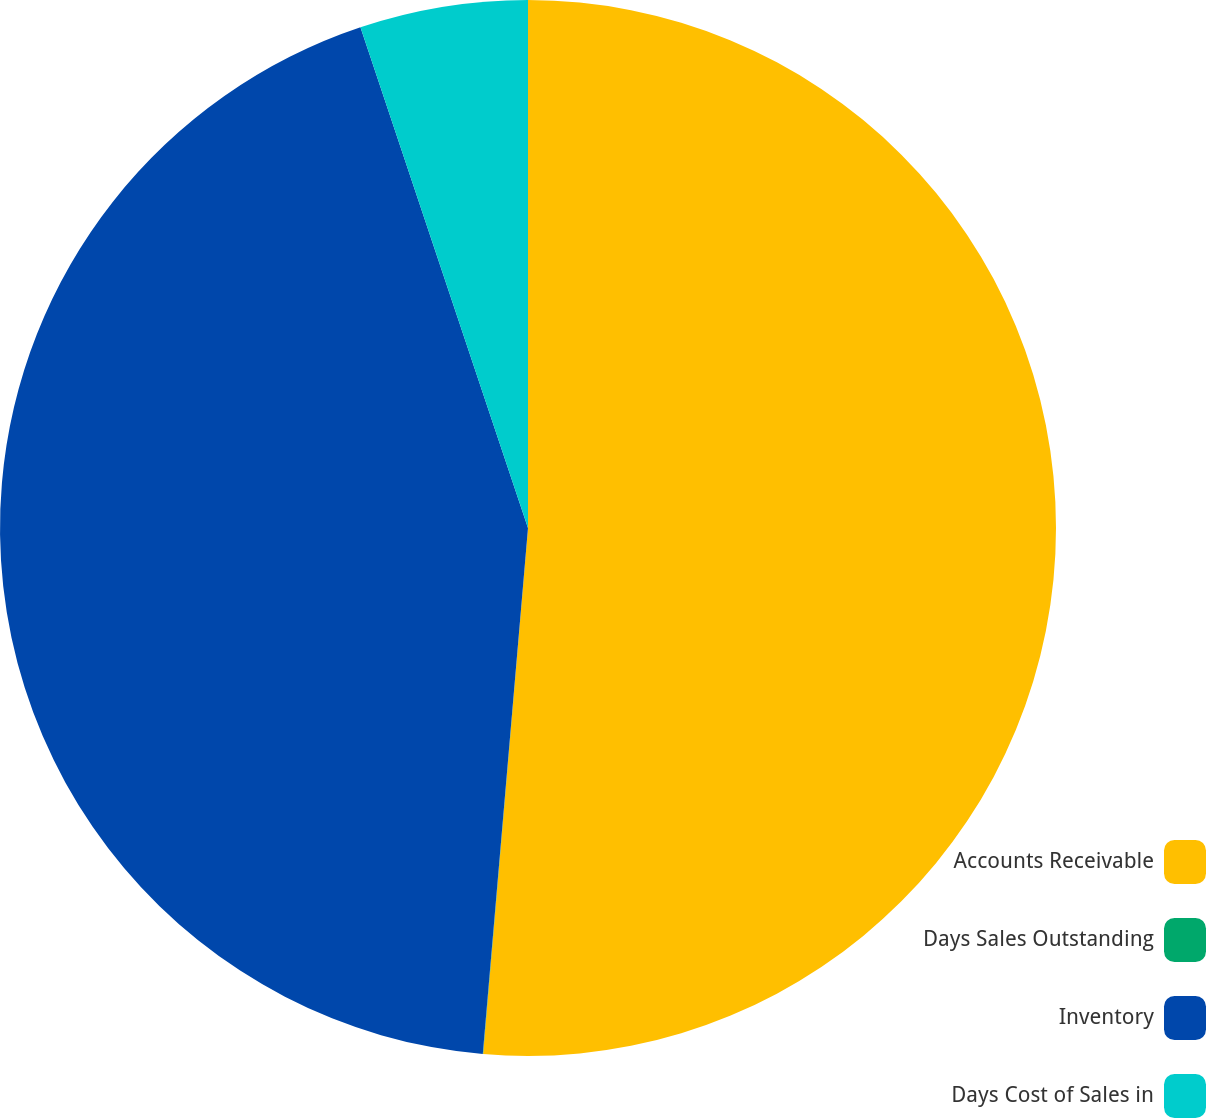Convert chart. <chart><loc_0><loc_0><loc_500><loc_500><pie_chart><fcel>Accounts Receivable<fcel>Days Sales Outstanding<fcel>Inventory<fcel>Days Cost of Sales in<nl><fcel>51.36%<fcel>0.01%<fcel>43.5%<fcel>5.14%<nl></chart> 